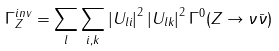Convert formula to latex. <formula><loc_0><loc_0><loc_500><loc_500>\Gamma _ { Z } ^ { i n v } = \sum _ { l } \sum _ { i , k } { | U _ { l i } | } ^ { 2 } \, { | U _ { l k } | } ^ { 2 } \, \Gamma ^ { 0 } ( Z \rightarrow \nu \bar { \nu } )</formula> 